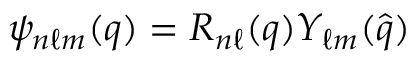Convert formula to latex. <formula><loc_0><loc_0><loc_500><loc_500>{ \psi _ { n \ell m } ( q ) = R _ { n \ell } ( q ) Y _ { \ell m } ( \hat { q } ) }</formula> 